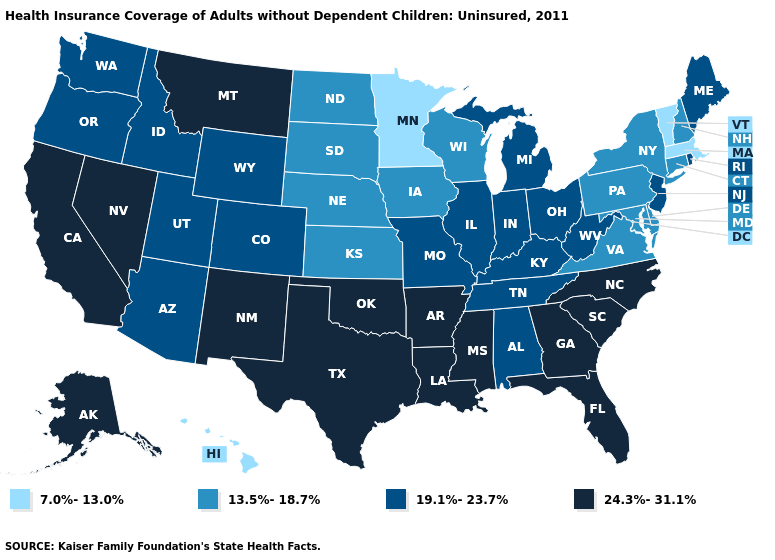Is the legend a continuous bar?
Quick response, please. No. What is the value of Utah?
Be succinct. 19.1%-23.7%. Name the states that have a value in the range 7.0%-13.0%?
Write a very short answer. Hawaii, Massachusetts, Minnesota, Vermont. Name the states that have a value in the range 24.3%-31.1%?
Give a very brief answer. Alaska, Arkansas, California, Florida, Georgia, Louisiana, Mississippi, Montana, Nevada, New Mexico, North Carolina, Oklahoma, South Carolina, Texas. Which states have the highest value in the USA?
Keep it brief. Alaska, Arkansas, California, Florida, Georgia, Louisiana, Mississippi, Montana, Nevada, New Mexico, North Carolina, Oklahoma, South Carolina, Texas. Among the states that border Missouri , which have the lowest value?
Quick response, please. Iowa, Kansas, Nebraska. Does Wyoming have a lower value than Georgia?
Quick response, please. Yes. Name the states that have a value in the range 7.0%-13.0%?
Concise answer only. Hawaii, Massachusetts, Minnesota, Vermont. What is the highest value in the MidWest ?
Concise answer only. 19.1%-23.7%. How many symbols are there in the legend?
Short answer required. 4. What is the lowest value in states that border Kansas?
Write a very short answer. 13.5%-18.7%. Name the states that have a value in the range 7.0%-13.0%?
Answer briefly. Hawaii, Massachusetts, Minnesota, Vermont. Does Colorado have a lower value than Maryland?
Give a very brief answer. No. Name the states that have a value in the range 7.0%-13.0%?
Quick response, please. Hawaii, Massachusetts, Minnesota, Vermont. Does Florida have the highest value in the USA?
Quick response, please. Yes. 